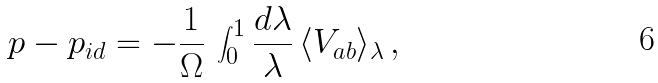<formula> <loc_0><loc_0><loc_500><loc_500>p - p _ { i d } = - \frac { 1 } { \Omega } \, \int _ { 0 } ^ { 1 } \frac { d \lambda } { \lambda } \, \langle V _ { a b } \rangle _ { \lambda } \, ,</formula> 